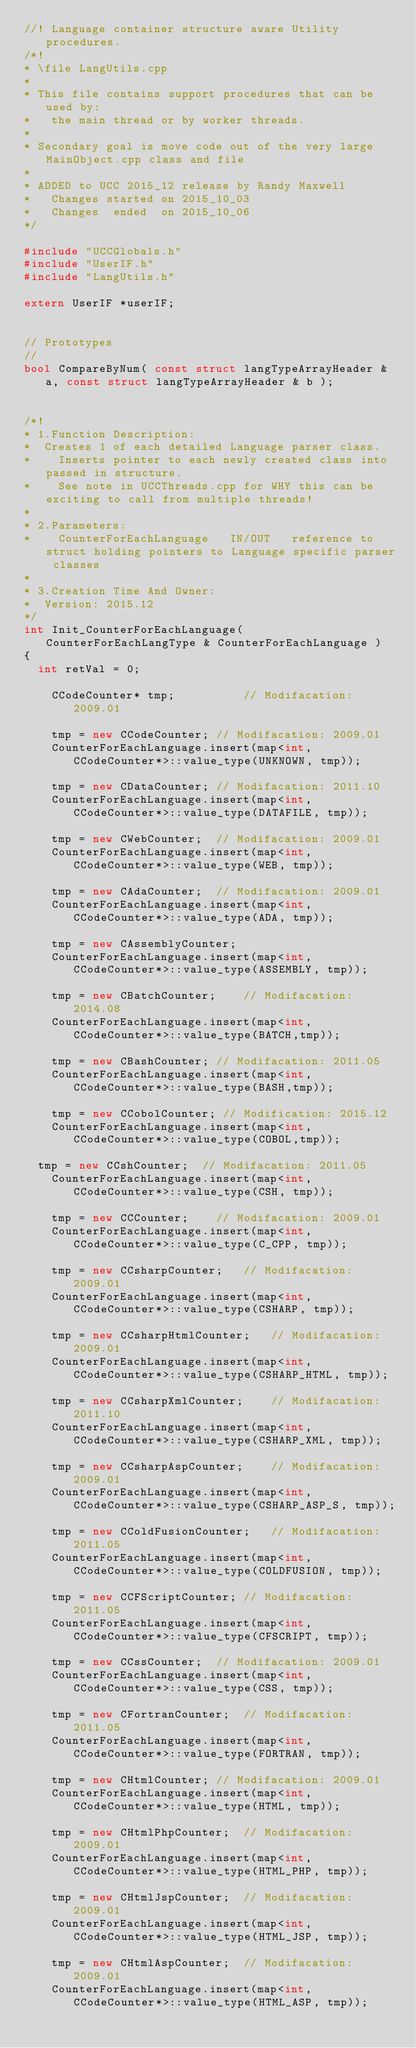<code> <loc_0><loc_0><loc_500><loc_500><_C++_>//! Language container structure aware Utility procedures.
/*!
* \file LangUtils.cpp
*
* This file contains support procedures that can be used by:
*   the main thread or by worker threads.
*
* Secondary goal is move code out of the very large MainObject.cpp class and file
*
* ADDED to UCC 2015_12 release by Randy Maxwell
*   Changes started on 2015_10_03
*   Changes  ended  on 2015_10_06
*/

#include "UCCGlobals.h"
#include "UserIF.h"
#include "LangUtils.h"

extern UserIF *userIF;


// Prototypes
//
bool CompareByNum( const struct langTypeArrayHeader & a, const struct langTypeArrayHeader & b );


/*!
* 1.Function Description:
*	 Creates 1 of each detailed Language parser class.
*    Inserts pointer to each newly created class into passed in structure.
*    See note in UCCThreads.cpp for WHY this can be exciting to call from multiple threads!
*
* 2.Parameters:
*    CounterForEachLanguage   IN/OUT   reference to struct holding pointers to Language specific parser classes
*
* 3.Creation Time And Owner:
*	 Version: 2015.12
*/
int Init_CounterForEachLanguage( CounterForEachLangType & CounterForEachLanguage )
{
	int retVal = 0;

    CCodeCounter* tmp;          // Modifacation: 2009.01

    tmp = new CCodeCounter; // Modifacation: 2009.01
    CounterForEachLanguage.insert(map<int, CCodeCounter*>::value_type(UNKNOWN, tmp));

    tmp = new CDataCounter; // Modifacation: 2011.10
    CounterForEachLanguage.insert(map<int, CCodeCounter*>::value_type(DATAFILE, tmp));

    tmp = new CWebCounter;  // Modifacation: 2009.01
    CounterForEachLanguage.insert(map<int, CCodeCounter*>::value_type(WEB, tmp));

    tmp = new CAdaCounter;  // Modifacation: 2009.01
    CounterForEachLanguage.insert(map<int, CCodeCounter*>::value_type(ADA, tmp));

    tmp = new CAssemblyCounter;
    CounterForEachLanguage.insert(map<int, CCodeCounter*>::value_type(ASSEMBLY, tmp));

    tmp = new CBatchCounter;    // Modifacation: 2014.08
    CounterForEachLanguage.insert(map<int, CCodeCounter*>::value_type(BATCH,tmp));

    tmp = new CBashCounter; // Modifacation: 2011.05
    CounterForEachLanguage.insert(map<int, CCodeCounter*>::value_type(BASH,tmp));

    tmp = new CCobolCounter; // Modification: 2015.12
    CounterForEachLanguage.insert(map<int, CCodeCounter*>::value_type(COBOL,tmp));

	tmp = new CCshCounter;  // Modifacation: 2011.05
    CounterForEachLanguage.insert(map<int, CCodeCounter*>::value_type(CSH, tmp));

    tmp = new CCCounter;    // Modifacation: 2009.01
    CounterForEachLanguage.insert(map<int, CCodeCounter*>::value_type(C_CPP, tmp));

    tmp = new CCsharpCounter;   // Modifacation: 2009.01
    CounterForEachLanguage.insert(map<int, CCodeCounter*>::value_type(CSHARP, tmp));

    tmp = new CCsharpHtmlCounter;   // Modifacation: 2009.01
    CounterForEachLanguage.insert(map<int, CCodeCounter*>::value_type(CSHARP_HTML, tmp));

    tmp = new CCsharpXmlCounter;    // Modifacation: 2011.10
    CounterForEachLanguage.insert(map<int, CCodeCounter*>::value_type(CSHARP_XML, tmp));

    tmp = new CCsharpAspCounter;    // Modifacation: 2009.01
    CounterForEachLanguage.insert(map<int, CCodeCounter*>::value_type(CSHARP_ASP_S, tmp));

    tmp = new CColdFusionCounter;   // Modifacation: 2011.05
    CounterForEachLanguage.insert(map<int, CCodeCounter*>::value_type(COLDFUSION, tmp));

    tmp = new CCFScriptCounter; // Modifacation: 2011.05
    CounterForEachLanguage.insert(map<int, CCodeCounter*>::value_type(CFSCRIPT, tmp));

    tmp = new CCssCounter;  // Modifacation: 2009.01
    CounterForEachLanguage.insert(map<int, CCodeCounter*>::value_type(CSS, tmp));

    tmp = new CFortranCounter;  // Modifacation: 2011.05
    CounterForEachLanguage.insert(map<int, CCodeCounter*>::value_type(FORTRAN, tmp));

    tmp = new CHtmlCounter; // Modifacation: 2009.01
    CounterForEachLanguage.insert(map<int, CCodeCounter*>::value_type(HTML, tmp));

    tmp = new CHtmlPhpCounter;  // Modifacation: 2009.01
    CounterForEachLanguage.insert(map<int, CCodeCounter*>::value_type(HTML_PHP, tmp));

    tmp = new CHtmlJspCounter;  // Modifacation: 2009.01
    CounterForEachLanguage.insert(map<int, CCodeCounter*>::value_type(HTML_JSP, tmp));

    tmp = new CHtmlAspCounter;  // Modifacation: 2009.01
    CounterForEachLanguage.insert(map<int, CCodeCounter*>::value_type(HTML_ASP, tmp));
</code> 